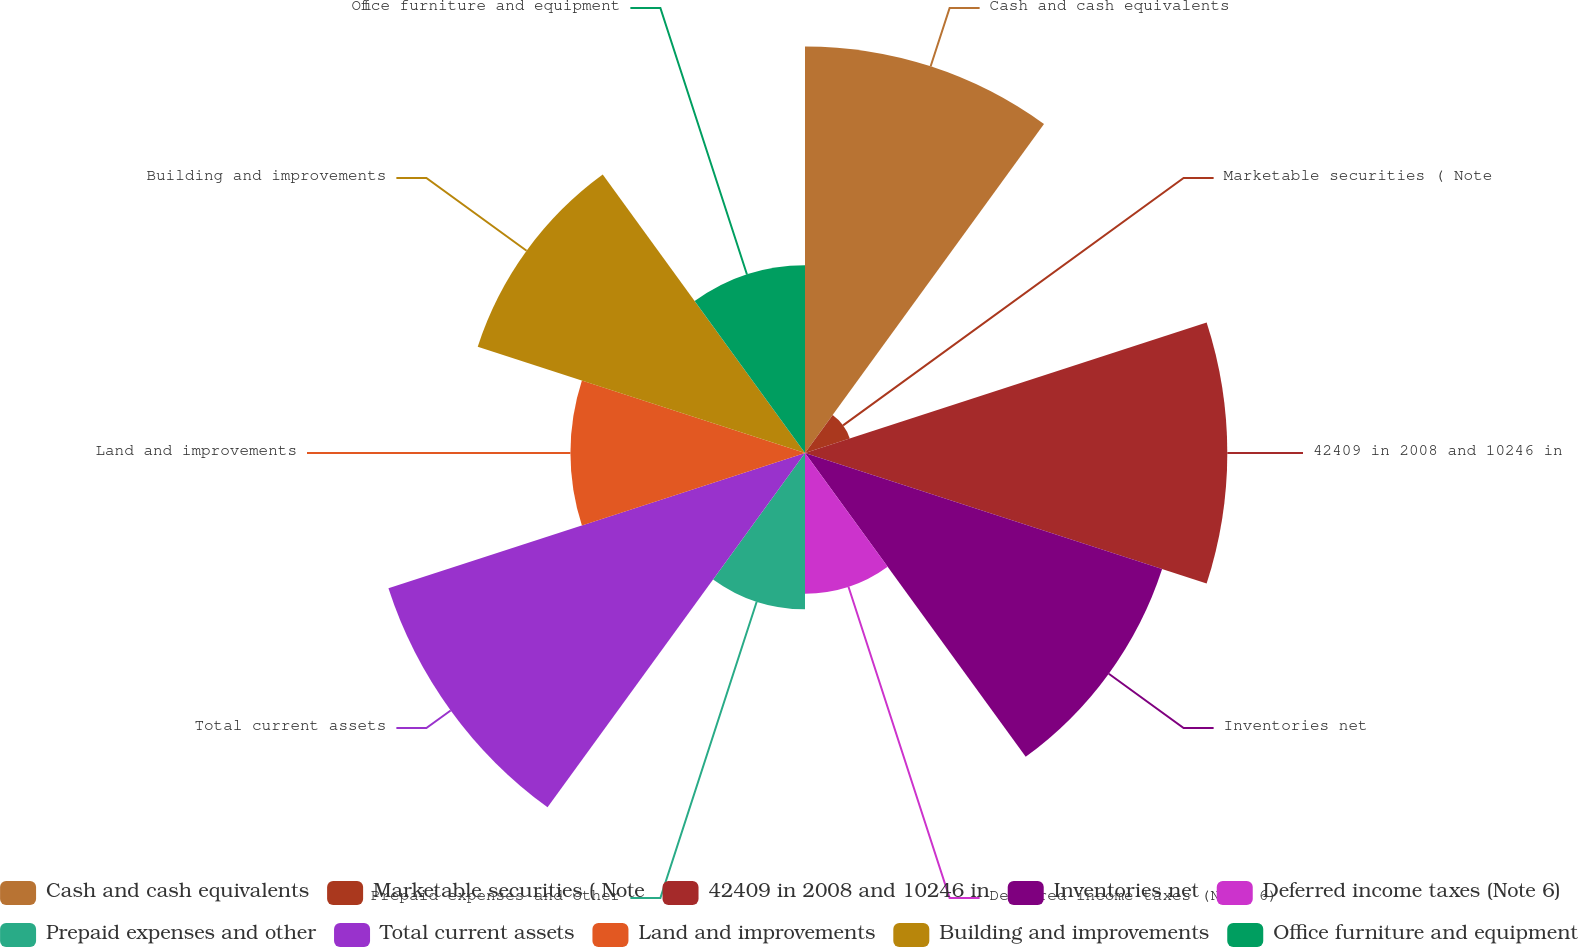Convert chart to OTSL. <chart><loc_0><loc_0><loc_500><loc_500><pie_chart><fcel>Cash and cash equivalents<fcel>Marketable securities ( Note<fcel>42409 in 2008 and 10246 in<fcel>Inventories net<fcel>Deferred income taxes (Note 6)<fcel>Prepaid expenses and other<fcel>Total current assets<fcel>Land and improvements<fcel>Building and improvements<fcel>Office furniture and equipment<nl><fcel>14.77%<fcel>1.71%<fcel>15.34%<fcel>13.64%<fcel>5.11%<fcel>5.68%<fcel>15.91%<fcel>8.52%<fcel>12.5%<fcel>6.82%<nl></chart> 